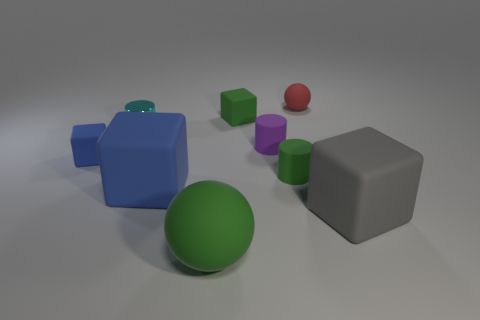Subtract all gray blocks. How many blocks are left? 3 Subtract all brown cubes. Subtract all gray cylinders. How many cubes are left? 4 Subtract all cylinders. How many objects are left? 6 Subtract all cyan metal cylinders. Subtract all small blocks. How many objects are left? 6 Add 6 small red matte objects. How many small red matte objects are left? 7 Add 8 gray rubber cylinders. How many gray rubber cylinders exist? 8 Subtract 2 blue blocks. How many objects are left? 7 